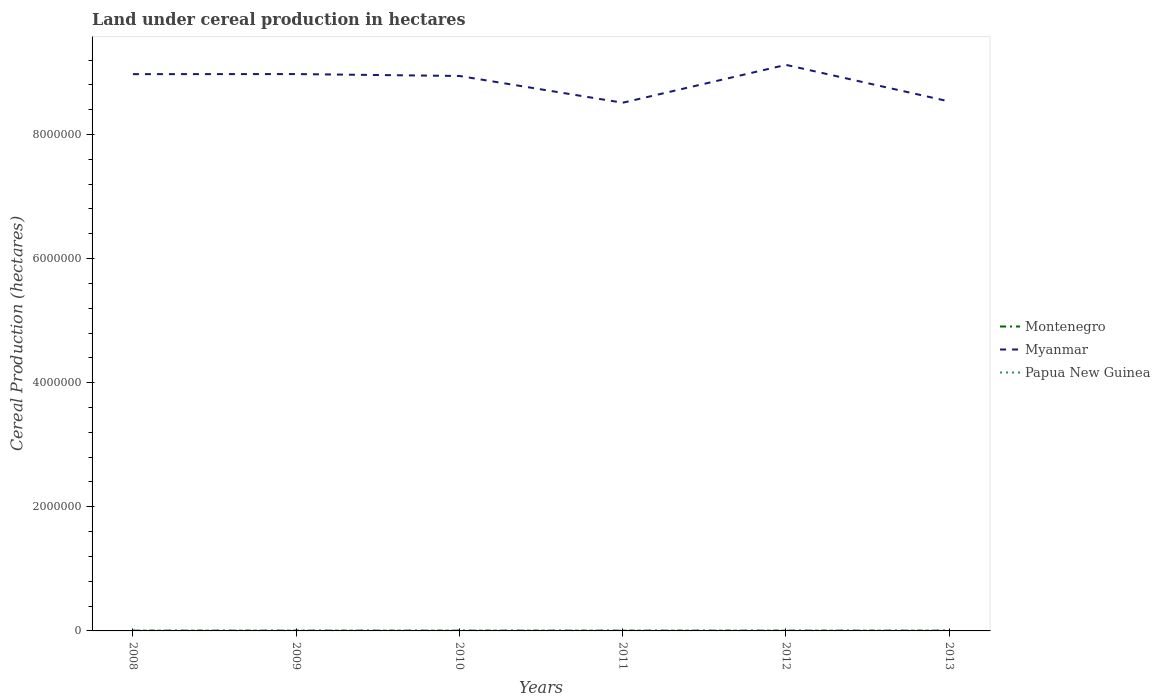How many different coloured lines are there?
Give a very brief answer. 3. Does the line corresponding to Myanmar intersect with the line corresponding to Papua New Guinea?
Keep it short and to the point. No. Across all years, what is the maximum land under cereal production in Papua New Guinea?
Ensure brevity in your answer.  3500. What is the total land under cereal production in Myanmar in the graph?
Your answer should be compact. -1.48e+05. What is the difference between the highest and the second highest land under cereal production in Myanmar?
Offer a very short reply. 6.10e+05. What is the difference between the highest and the lowest land under cereal production in Papua New Guinea?
Your response must be concise. 3. Is the land under cereal production in Papua New Guinea strictly greater than the land under cereal production in Myanmar over the years?
Offer a terse response. Yes. How many lines are there?
Your answer should be very brief. 3. How many years are there in the graph?
Offer a very short reply. 6. What is the difference between two consecutive major ticks on the Y-axis?
Your response must be concise. 2.00e+06. Does the graph contain grids?
Your response must be concise. No. Where does the legend appear in the graph?
Keep it short and to the point. Center right. How many legend labels are there?
Provide a succinct answer. 3. What is the title of the graph?
Your answer should be compact. Land under cereal production in hectares. Does "Cambodia" appear as one of the legend labels in the graph?
Provide a short and direct response. No. What is the label or title of the X-axis?
Your answer should be very brief. Years. What is the label or title of the Y-axis?
Your answer should be compact. Cereal Production (hectares). What is the Cereal Production (hectares) of Montenegro in 2008?
Your answer should be compact. 4746. What is the Cereal Production (hectares) in Myanmar in 2008?
Make the answer very short. 8.97e+06. What is the Cereal Production (hectares) in Papua New Guinea in 2008?
Keep it short and to the point. 3588. What is the Cereal Production (hectares) of Montenegro in 2009?
Offer a terse response. 4841. What is the Cereal Production (hectares) of Myanmar in 2009?
Provide a short and direct response. 8.97e+06. What is the Cereal Production (hectares) in Papua New Guinea in 2009?
Offer a terse response. 3676. What is the Cereal Production (hectares) in Montenegro in 2010?
Offer a very short reply. 4653. What is the Cereal Production (hectares) in Myanmar in 2010?
Provide a succinct answer. 8.94e+06. What is the Cereal Production (hectares) in Papua New Guinea in 2010?
Your answer should be very brief. 3762. What is the Cereal Production (hectares) in Montenegro in 2011?
Your answer should be compact. 4795. What is the Cereal Production (hectares) of Myanmar in 2011?
Your answer should be compact. 8.51e+06. What is the Cereal Production (hectares) of Papua New Guinea in 2011?
Provide a short and direct response. 3850. What is the Cereal Production (hectares) in Montenegro in 2012?
Provide a short and direct response. 4656. What is the Cereal Production (hectares) of Myanmar in 2012?
Keep it short and to the point. 9.12e+06. What is the Cereal Production (hectares) of Papua New Guinea in 2012?
Give a very brief answer. 3500. What is the Cereal Production (hectares) of Montenegro in 2013?
Ensure brevity in your answer.  4870. What is the Cereal Production (hectares) of Myanmar in 2013?
Make the answer very short. 8.53e+06. What is the Cereal Production (hectares) in Papua New Guinea in 2013?
Offer a terse response. 3700. Across all years, what is the maximum Cereal Production (hectares) in Montenegro?
Your answer should be compact. 4870. Across all years, what is the maximum Cereal Production (hectares) in Myanmar?
Give a very brief answer. 9.12e+06. Across all years, what is the maximum Cereal Production (hectares) of Papua New Guinea?
Provide a succinct answer. 3850. Across all years, what is the minimum Cereal Production (hectares) of Montenegro?
Ensure brevity in your answer.  4653. Across all years, what is the minimum Cereal Production (hectares) of Myanmar?
Your answer should be compact. 8.51e+06. Across all years, what is the minimum Cereal Production (hectares) in Papua New Guinea?
Provide a short and direct response. 3500. What is the total Cereal Production (hectares) in Montenegro in the graph?
Make the answer very short. 2.86e+04. What is the total Cereal Production (hectares) in Myanmar in the graph?
Your answer should be compact. 5.31e+07. What is the total Cereal Production (hectares) of Papua New Guinea in the graph?
Give a very brief answer. 2.21e+04. What is the difference between the Cereal Production (hectares) of Montenegro in 2008 and that in 2009?
Offer a very short reply. -95. What is the difference between the Cereal Production (hectares) of Myanmar in 2008 and that in 2009?
Make the answer very short. -1142. What is the difference between the Cereal Production (hectares) of Papua New Guinea in 2008 and that in 2009?
Give a very brief answer. -88. What is the difference between the Cereal Production (hectares) of Montenegro in 2008 and that in 2010?
Provide a succinct answer. 93. What is the difference between the Cereal Production (hectares) of Myanmar in 2008 and that in 2010?
Make the answer very short. 2.97e+04. What is the difference between the Cereal Production (hectares) in Papua New Guinea in 2008 and that in 2010?
Give a very brief answer. -174. What is the difference between the Cereal Production (hectares) in Montenegro in 2008 and that in 2011?
Make the answer very short. -49. What is the difference between the Cereal Production (hectares) of Myanmar in 2008 and that in 2011?
Your answer should be compact. 4.61e+05. What is the difference between the Cereal Production (hectares) in Papua New Guinea in 2008 and that in 2011?
Keep it short and to the point. -262. What is the difference between the Cereal Production (hectares) in Myanmar in 2008 and that in 2012?
Make the answer very short. -1.49e+05. What is the difference between the Cereal Production (hectares) in Montenegro in 2008 and that in 2013?
Your answer should be compact. -124. What is the difference between the Cereal Production (hectares) in Myanmar in 2008 and that in 2013?
Ensure brevity in your answer.  4.40e+05. What is the difference between the Cereal Production (hectares) in Papua New Guinea in 2008 and that in 2013?
Your response must be concise. -112. What is the difference between the Cereal Production (hectares) of Montenegro in 2009 and that in 2010?
Give a very brief answer. 188. What is the difference between the Cereal Production (hectares) of Myanmar in 2009 and that in 2010?
Ensure brevity in your answer.  3.08e+04. What is the difference between the Cereal Production (hectares) of Papua New Guinea in 2009 and that in 2010?
Give a very brief answer. -86. What is the difference between the Cereal Production (hectares) of Montenegro in 2009 and that in 2011?
Provide a succinct answer. 46. What is the difference between the Cereal Production (hectares) of Myanmar in 2009 and that in 2011?
Offer a terse response. 4.62e+05. What is the difference between the Cereal Production (hectares) in Papua New Guinea in 2009 and that in 2011?
Make the answer very short. -174. What is the difference between the Cereal Production (hectares) in Montenegro in 2009 and that in 2012?
Offer a very short reply. 185. What is the difference between the Cereal Production (hectares) of Myanmar in 2009 and that in 2012?
Give a very brief answer. -1.48e+05. What is the difference between the Cereal Production (hectares) of Papua New Guinea in 2009 and that in 2012?
Your answer should be compact. 176. What is the difference between the Cereal Production (hectares) of Myanmar in 2009 and that in 2013?
Keep it short and to the point. 4.41e+05. What is the difference between the Cereal Production (hectares) of Montenegro in 2010 and that in 2011?
Offer a terse response. -142. What is the difference between the Cereal Production (hectares) in Myanmar in 2010 and that in 2011?
Keep it short and to the point. 4.31e+05. What is the difference between the Cereal Production (hectares) of Papua New Guinea in 2010 and that in 2011?
Keep it short and to the point. -88. What is the difference between the Cereal Production (hectares) of Myanmar in 2010 and that in 2012?
Provide a short and direct response. -1.79e+05. What is the difference between the Cereal Production (hectares) in Papua New Guinea in 2010 and that in 2012?
Make the answer very short. 262. What is the difference between the Cereal Production (hectares) in Montenegro in 2010 and that in 2013?
Your answer should be compact. -217. What is the difference between the Cereal Production (hectares) of Myanmar in 2010 and that in 2013?
Offer a terse response. 4.10e+05. What is the difference between the Cereal Production (hectares) of Papua New Guinea in 2010 and that in 2013?
Offer a very short reply. 62. What is the difference between the Cereal Production (hectares) of Montenegro in 2011 and that in 2012?
Provide a succinct answer. 139. What is the difference between the Cereal Production (hectares) of Myanmar in 2011 and that in 2012?
Keep it short and to the point. -6.10e+05. What is the difference between the Cereal Production (hectares) of Papua New Guinea in 2011 and that in 2012?
Offer a terse response. 350. What is the difference between the Cereal Production (hectares) of Montenegro in 2011 and that in 2013?
Offer a very short reply. -75. What is the difference between the Cereal Production (hectares) in Myanmar in 2011 and that in 2013?
Provide a short and direct response. -2.06e+04. What is the difference between the Cereal Production (hectares) of Papua New Guinea in 2011 and that in 2013?
Offer a very short reply. 150. What is the difference between the Cereal Production (hectares) in Montenegro in 2012 and that in 2013?
Ensure brevity in your answer.  -214. What is the difference between the Cereal Production (hectares) of Myanmar in 2012 and that in 2013?
Your response must be concise. 5.90e+05. What is the difference between the Cereal Production (hectares) of Papua New Guinea in 2012 and that in 2013?
Give a very brief answer. -200. What is the difference between the Cereal Production (hectares) in Montenegro in 2008 and the Cereal Production (hectares) in Myanmar in 2009?
Offer a terse response. -8.97e+06. What is the difference between the Cereal Production (hectares) in Montenegro in 2008 and the Cereal Production (hectares) in Papua New Guinea in 2009?
Give a very brief answer. 1070. What is the difference between the Cereal Production (hectares) of Myanmar in 2008 and the Cereal Production (hectares) of Papua New Guinea in 2009?
Provide a short and direct response. 8.97e+06. What is the difference between the Cereal Production (hectares) of Montenegro in 2008 and the Cereal Production (hectares) of Myanmar in 2010?
Keep it short and to the point. -8.94e+06. What is the difference between the Cereal Production (hectares) in Montenegro in 2008 and the Cereal Production (hectares) in Papua New Guinea in 2010?
Your answer should be compact. 984. What is the difference between the Cereal Production (hectares) in Myanmar in 2008 and the Cereal Production (hectares) in Papua New Guinea in 2010?
Provide a succinct answer. 8.97e+06. What is the difference between the Cereal Production (hectares) of Montenegro in 2008 and the Cereal Production (hectares) of Myanmar in 2011?
Make the answer very short. -8.51e+06. What is the difference between the Cereal Production (hectares) of Montenegro in 2008 and the Cereal Production (hectares) of Papua New Guinea in 2011?
Offer a very short reply. 896. What is the difference between the Cereal Production (hectares) in Myanmar in 2008 and the Cereal Production (hectares) in Papua New Guinea in 2011?
Keep it short and to the point. 8.97e+06. What is the difference between the Cereal Production (hectares) of Montenegro in 2008 and the Cereal Production (hectares) of Myanmar in 2012?
Provide a short and direct response. -9.12e+06. What is the difference between the Cereal Production (hectares) of Montenegro in 2008 and the Cereal Production (hectares) of Papua New Guinea in 2012?
Your answer should be very brief. 1246. What is the difference between the Cereal Production (hectares) of Myanmar in 2008 and the Cereal Production (hectares) of Papua New Guinea in 2012?
Provide a succinct answer. 8.97e+06. What is the difference between the Cereal Production (hectares) of Montenegro in 2008 and the Cereal Production (hectares) of Myanmar in 2013?
Your answer should be very brief. -8.53e+06. What is the difference between the Cereal Production (hectares) of Montenegro in 2008 and the Cereal Production (hectares) of Papua New Guinea in 2013?
Offer a very short reply. 1046. What is the difference between the Cereal Production (hectares) of Myanmar in 2008 and the Cereal Production (hectares) of Papua New Guinea in 2013?
Keep it short and to the point. 8.97e+06. What is the difference between the Cereal Production (hectares) in Montenegro in 2009 and the Cereal Production (hectares) in Myanmar in 2010?
Keep it short and to the point. -8.94e+06. What is the difference between the Cereal Production (hectares) in Montenegro in 2009 and the Cereal Production (hectares) in Papua New Guinea in 2010?
Provide a short and direct response. 1079. What is the difference between the Cereal Production (hectares) of Myanmar in 2009 and the Cereal Production (hectares) of Papua New Guinea in 2010?
Provide a succinct answer. 8.97e+06. What is the difference between the Cereal Production (hectares) in Montenegro in 2009 and the Cereal Production (hectares) in Myanmar in 2011?
Give a very brief answer. -8.51e+06. What is the difference between the Cereal Production (hectares) of Montenegro in 2009 and the Cereal Production (hectares) of Papua New Guinea in 2011?
Provide a short and direct response. 991. What is the difference between the Cereal Production (hectares) of Myanmar in 2009 and the Cereal Production (hectares) of Papua New Guinea in 2011?
Provide a short and direct response. 8.97e+06. What is the difference between the Cereal Production (hectares) of Montenegro in 2009 and the Cereal Production (hectares) of Myanmar in 2012?
Your answer should be very brief. -9.12e+06. What is the difference between the Cereal Production (hectares) of Montenegro in 2009 and the Cereal Production (hectares) of Papua New Guinea in 2012?
Make the answer very short. 1341. What is the difference between the Cereal Production (hectares) of Myanmar in 2009 and the Cereal Production (hectares) of Papua New Guinea in 2012?
Ensure brevity in your answer.  8.97e+06. What is the difference between the Cereal Production (hectares) of Montenegro in 2009 and the Cereal Production (hectares) of Myanmar in 2013?
Provide a succinct answer. -8.53e+06. What is the difference between the Cereal Production (hectares) in Montenegro in 2009 and the Cereal Production (hectares) in Papua New Guinea in 2013?
Provide a succinct answer. 1141. What is the difference between the Cereal Production (hectares) of Myanmar in 2009 and the Cereal Production (hectares) of Papua New Guinea in 2013?
Give a very brief answer. 8.97e+06. What is the difference between the Cereal Production (hectares) in Montenegro in 2010 and the Cereal Production (hectares) in Myanmar in 2011?
Your response must be concise. -8.51e+06. What is the difference between the Cereal Production (hectares) in Montenegro in 2010 and the Cereal Production (hectares) in Papua New Guinea in 2011?
Offer a terse response. 803. What is the difference between the Cereal Production (hectares) of Myanmar in 2010 and the Cereal Production (hectares) of Papua New Guinea in 2011?
Your response must be concise. 8.94e+06. What is the difference between the Cereal Production (hectares) of Montenegro in 2010 and the Cereal Production (hectares) of Myanmar in 2012?
Offer a very short reply. -9.12e+06. What is the difference between the Cereal Production (hectares) of Montenegro in 2010 and the Cereal Production (hectares) of Papua New Guinea in 2012?
Offer a terse response. 1153. What is the difference between the Cereal Production (hectares) of Myanmar in 2010 and the Cereal Production (hectares) of Papua New Guinea in 2012?
Offer a very short reply. 8.94e+06. What is the difference between the Cereal Production (hectares) of Montenegro in 2010 and the Cereal Production (hectares) of Myanmar in 2013?
Make the answer very short. -8.53e+06. What is the difference between the Cereal Production (hectares) of Montenegro in 2010 and the Cereal Production (hectares) of Papua New Guinea in 2013?
Ensure brevity in your answer.  953. What is the difference between the Cereal Production (hectares) of Myanmar in 2010 and the Cereal Production (hectares) of Papua New Guinea in 2013?
Provide a short and direct response. 8.94e+06. What is the difference between the Cereal Production (hectares) in Montenegro in 2011 and the Cereal Production (hectares) in Myanmar in 2012?
Your answer should be compact. -9.12e+06. What is the difference between the Cereal Production (hectares) in Montenegro in 2011 and the Cereal Production (hectares) in Papua New Guinea in 2012?
Provide a short and direct response. 1295. What is the difference between the Cereal Production (hectares) in Myanmar in 2011 and the Cereal Production (hectares) in Papua New Guinea in 2012?
Offer a terse response. 8.51e+06. What is the difference between the Cereal Production (hectares) in Montenegro in 2011 and the Cereal Production (hectares) in Myanmar in 2013?
Your answer should be very brief. -8.53e+06. What is the difference between the Cereal Production (hectares) in Montenegro in 2011 and the Cereal Production (hectares) in Papua New Guinea in 2013?
Offer a very short reply. 1095. What is the difference between the Cereal Production (hectares) of Myanmar in 2011 and the Cereal Production (hectares) of Papua New Guinea in 2013?
Ensure brevity in your answer.  8.51e+06. What is the difference between the Cereal Production (hectares) of Montenegro in 2012 and the Cereal Production (hectares) of Myanmar in 2013?
Give a very brief answer. -8.53e+06. What is the difference between the Cereal Production (hectares) of Montenegro in 2012 and the Cereal Production (hectares) of Papua New Guinea in 2013?
Make the answer very short. 956. What is the difference between the Cereal Production (hectares) of Myanmar in 2012 and the Cereal Production (hectares) of Papua New Guinea in 2013?
Your answer should be compact. 9.12e+06. What is the average Cereal Production (hectares) in Montenegro per year?
Ensure brevity in your answer.  4760.17. What is the average Cereal Production (hectares) of Myanmar per year?
Provide a short and direct response. 8.84e+06. What is the average Cereal Production (hectares) of Papua New Guinea per year?
Keep it short and to the point. 3679.33. In the year 2008, what is the difference between the Cereal Production (hectares) in Montenegro and Cereal Production (hectares) in Myanmar?
Give a very brief answer. -8.97e+06. In the year 2008, what is the difference between the Cereal Production (hectares) in Montenegro and Cereal Production (hectares) in Papua New Guinea?
Your answer should be very brief. 1158. In the year 2008, what is the difference between the Cereal Production (hectares) in Myanmar and Cereal Production (hectares) in Papua New Guinea?
Ensure brevity in your answer.  8.97e+06. In the year 2009, what is the difference between the Cereal Production (hectares) in Montenegro and Cereal Production (hectares) in Myanmar?
Provide a succinct answer. -8.97e+06. In the year 2009, what is the difference between the Cereal Production (hectares) of Montenegro and Cereal Production (hectares) of Papua New Guinea?
Offer a very short reply. 1165. In the year 2009, what is the difference between the Cereal Production (hectares) in Myanmar and Cereal Production (hectares) in Papua New Guinea?
Your answer should be very brief. 8.97e+06. In the year 2010, what is the difference between the Cereal Production (hectares) in Montenegro and Cereal Production (hectares) in Myanmar?
Give a very brief answer. -8.94e+06. In the year 2010, what is the difference between the Cereal Production (hectares) of Montenegro and Cereal Production (hectares) of Papua New Guinea?
Provide a succinct answer. 891. In the year 2010, what is the difference between the Cereal Production (hectares) in Myanmar and Cereal Production (hectares) in Papua New Guinea?
Keep it short and to the point. 8.94e+06. In the year 2011, what is the difference between the Cereal Production (hectares) of Montenegro and Cereal Production (hectares) of Myanmar?
Make the answer very short. -8.51e+06. In the year 2011, what is the difference between the Cereal Production (hectares) of Montenegro and Cereal Production (hectares) of Papua New Guinea?
Provide a succinct answer. 945. In the year 2011, what is the difference between the Cereal Production (hectares) of Myanmar and Cereal Production (hectares) of Papua New Guinea?
Your answer should be compact. 8.51e+06. In the year 2012, what is the difference between the Cereal Production (hectares) in Montenegro and Cereal Production (hectares) in Myanmar?
Provide a succinct answer. -9.12e+06. In the year 2012, what is the difference between the Cereal Production (hectares) of Montenegro and Cereal Production (hectares) of Papua New Guinea?
Your answer should be compact. 1156. In the year 2012, what is the difference between the Cereal Production (hectares) in Myanmar and Cereal Production (hectares) in Papua New Guinea?
Offer a terse response. 9.12e+06. In the year 2013, what is the difference between the Cereal Production (hectares) of Montenegro and Cereal Production (hectares) of Myanmar?
Give a very brief answer. -8.53e+06. In the year 2013, what is the difference between the Cereal Production (hectares) of Montenegro and Cereal Production (hectares) of Papua New Guinea?
Your answer should be compact. 1170. In the year 2013, what is the difference between the Cereal Production (hectares) in Myanmar and Cereal Production (hectares) in Papua New Guinea?
Your answer should be compact. 8.53e+06. What is the ratio of the Cereal Production (hectares) of Montenegro in 2008 to that in 2009?
Provide a succinct answer. 0.98. What is the ratio of the Cereal Production (hectares) in Myanmar in 2008 to that in 2009?
Provide a short and direct response. 1. What is the ratio of the Cereal Production (hectares) of Papua New Guinea in 2008 to that in 2009?
Provide a succinct answer. 0.98. What is the ratio of the Cereal Production (hectares) of Montenegro in 2008 to that in 2010?
Your response must be concise. 1.02. What is the ratio of the Cereal Production (hectares) in Myanmar in 2008 to that in 2010?
Provide a short and direct response. 1. What is the ratio of the Cereal Production (hectares) of Papua New Guinea in 2008 to that in 2010?
Your answer should be very brief. 0.95. What is the ratio of the Cereal Production (hectares) in Myanmar in 2008 to that in 2011?
Keep it short and to the point. 1.05. What is the ratio of the Cereal Production (hectares) in Papua New Guinea in 2008 to that in 2011?
Provide a short and direct response. 0.93. What is the ratio of the Cereal Production (hectares) of Montenegro in 2008 to that in 2012?
Ensure brevity in your answer.  1.02. What is the ratio of the Cereal Production (hectares) in Myanmar in 2008 to that in 2012?
Your answer should be compact. 0.98. What is the ratio of the Cereal Production (hectares) of Papua New Guinea in 2008 to that in 2012?
Your response must be concise. 1.03. What is the ratio of the Cereal Production (hectares) of Montenegro in 2008 to that in 2013?
Provide a short and direct response. 0.97. What is the ratio of the Cereal Production (hectares) of Myanmar in 2008 to that in 2013?
Your response must be concise. 1.05. What is the ratio of the Cereal Production (hectares) in Papua New Guinea in 2008 to that in 2013?
Offer a very short reply. 0.97. What is the ratio of the Cereal Production (hectares) in Montenegro in 2009 to that in 2010?
Provide a short and direct response. 1.04. What is the ratio of the Cereal Production (hectares) in Myanmar in 2009 to that in 2010?
Give a very brief answer. 1. What is the ratio of the Cereal Production (hectares) of Papua New Guinea in 2009 to that in 2010?
Your response must be concise. 0.98. What is the ratio of the Cereal Production (hectares) of Montenegro in 2009 to that in 2011?
Provide a succinct answer. 1.01. What is the ratio of the Cereal Production (hectares) in Myanmar in 2009 to that in 2011?
Provide a short and direct response. 1.05. What is the ratio of the Cereal Production (hectares) in Papua New Guinea in 2009 to that in 2011?
Offer a terse response. 0.95. What is the ratio of the Cereal Production (hectares) of Montenegro in 2009 to that in 2012?
Offer a terse response. 1.04. What is the ratio of the Cereal Production (hectares) in Myanmar in 2009 to that in 2012?
Your response must be concise. 0.98. What is the ratio of the Cereal Production (hectares) of Papua New Guinea in 2009 to that in 2012?
Offer a very short reply. 1.05. What is the ratio of the Cereal Production (hectares) of Myanmar in 2009 to that in 2013?
Provide a short and direct response. 1.05. What is the ratio of the Cereal Production (hectares) in Montenegro in 2010 to that in 2011?
Your response must be concise. 0.97. What is the ratio of the Cereal Production (hectares) of Myanmar in 2010 to that in 2011?
Provide a succinct answer. 1.05. What is the ratio of the Cereal Production (hectares) of Papua New Guinea in 2010 to that in 2011?
Provide a short and direct response. 0.98. What is the ratio of the Cereal Production (hectares) in Myanmar in 2010 to that in 2012?
Your answer should be compact. 0.98. What is the ratio of the Cereal Production (hectares) in Papua New Guinea in 2010 to that in 2012?
Your answer should be very brief. 1.07. What is the ratio of the Cereal Production (hectares) of Montenegro in 2010 to that in 2013?
Your answer should be compact. 0.96. What is the ratio of the Cereal Production (hectares) of Myanmar in 2010 to that in 2013?
Your answer should be very brief. 1.05. What is the ratio of the Cereal Production (hectares) of Papua New Guinea in 2010 to that in 2013?
Your response must be concise. 1.02. What is the ratio of the Cereal Production (hectares) of Montenegro in 2011 to that in 2012?
Provide a succinct answer. 1.03. What is the ratio of the Cereal Production (hectares) of Myanmar in 2011 to that in 2012?
Offer a terse response. 0.93. What is the ratio of the Cereal Production (hectares) of Papua New Guinea in 2011 to that in 2012?
Provide a succinct answer. 1.1. What is the ratio of the Cereal Production (hectares) of Montenegro in 2011 to that in 2013?
Ensure brevity in your answer.  0.98. What is the ratio of the Cereal Production (hectares) of Myanmar in 2011 to that in 2013?
Give a very brief answer. 1. What is the ratio of the Cereal Production (hectares) of Papua New Guinea in 2011 to that in 2013?
Give a very brief answer. 1.04. What is the ratio of the Cereal Production (hectares) in Montenegro in 2012 to that in 2013?
Make the answer very short. 0.96. What is the ratio of the Cereal Production (hectares) of Myanmar in 2012 to that in 2013?
Give a very brief answer. 1.07. What is the ratio of the Cereal Production (hectares) in Papua New Guinea in 2012 to that in 2013?
Your answer should be compact. 0.95. What is the difference between the highest and the second highest Cereal Production (hectares) in Montenegro?
Your answer should be compact. 29. What is the difference between the highest and the second highest Cereal Production (hectares) in Myanmar?
Provide a succinct answer. 1.48e+05. What is the difference between the highest and the lowest Cereal Production (hectares) in Montenegro?
Your answer should be compact. 217. What is the difference between the highest and the lowest Cereal Production (hectares) of Myanmar?
Provide a short and direct response. 6.10e+05. What is the difference between the highest and the lowest Cereal Production (hectares) in Papua New Guinea?
Your answer should be very brief. 350. 